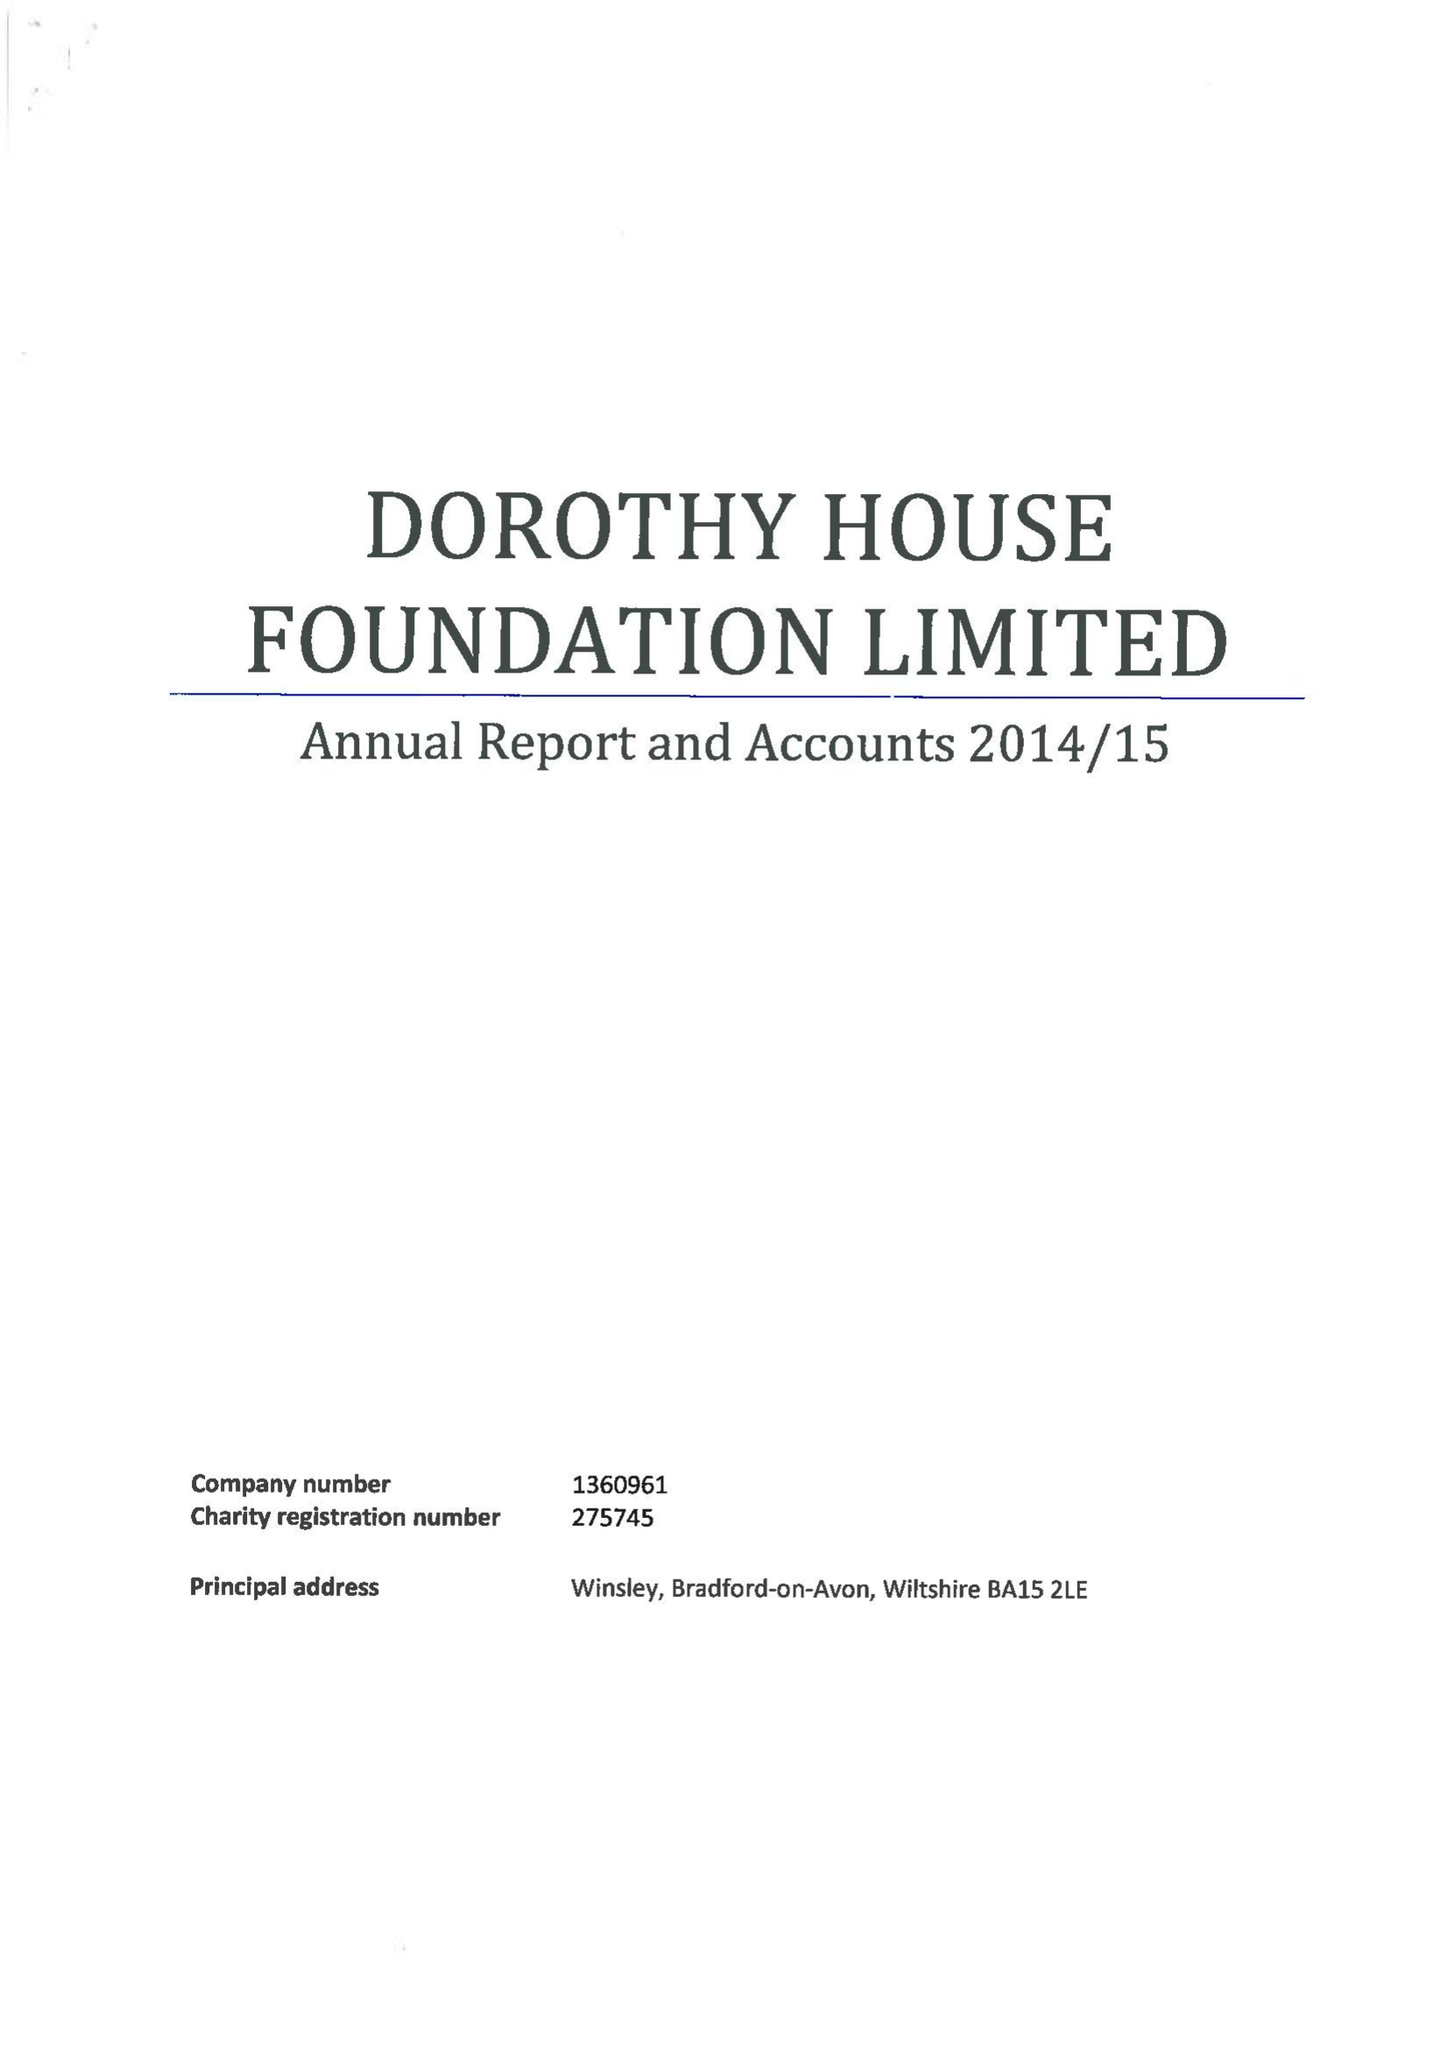What is the value for the charity_name?
Answer the question using a single word or phrase. Dorothy House Foundation Ltd. 